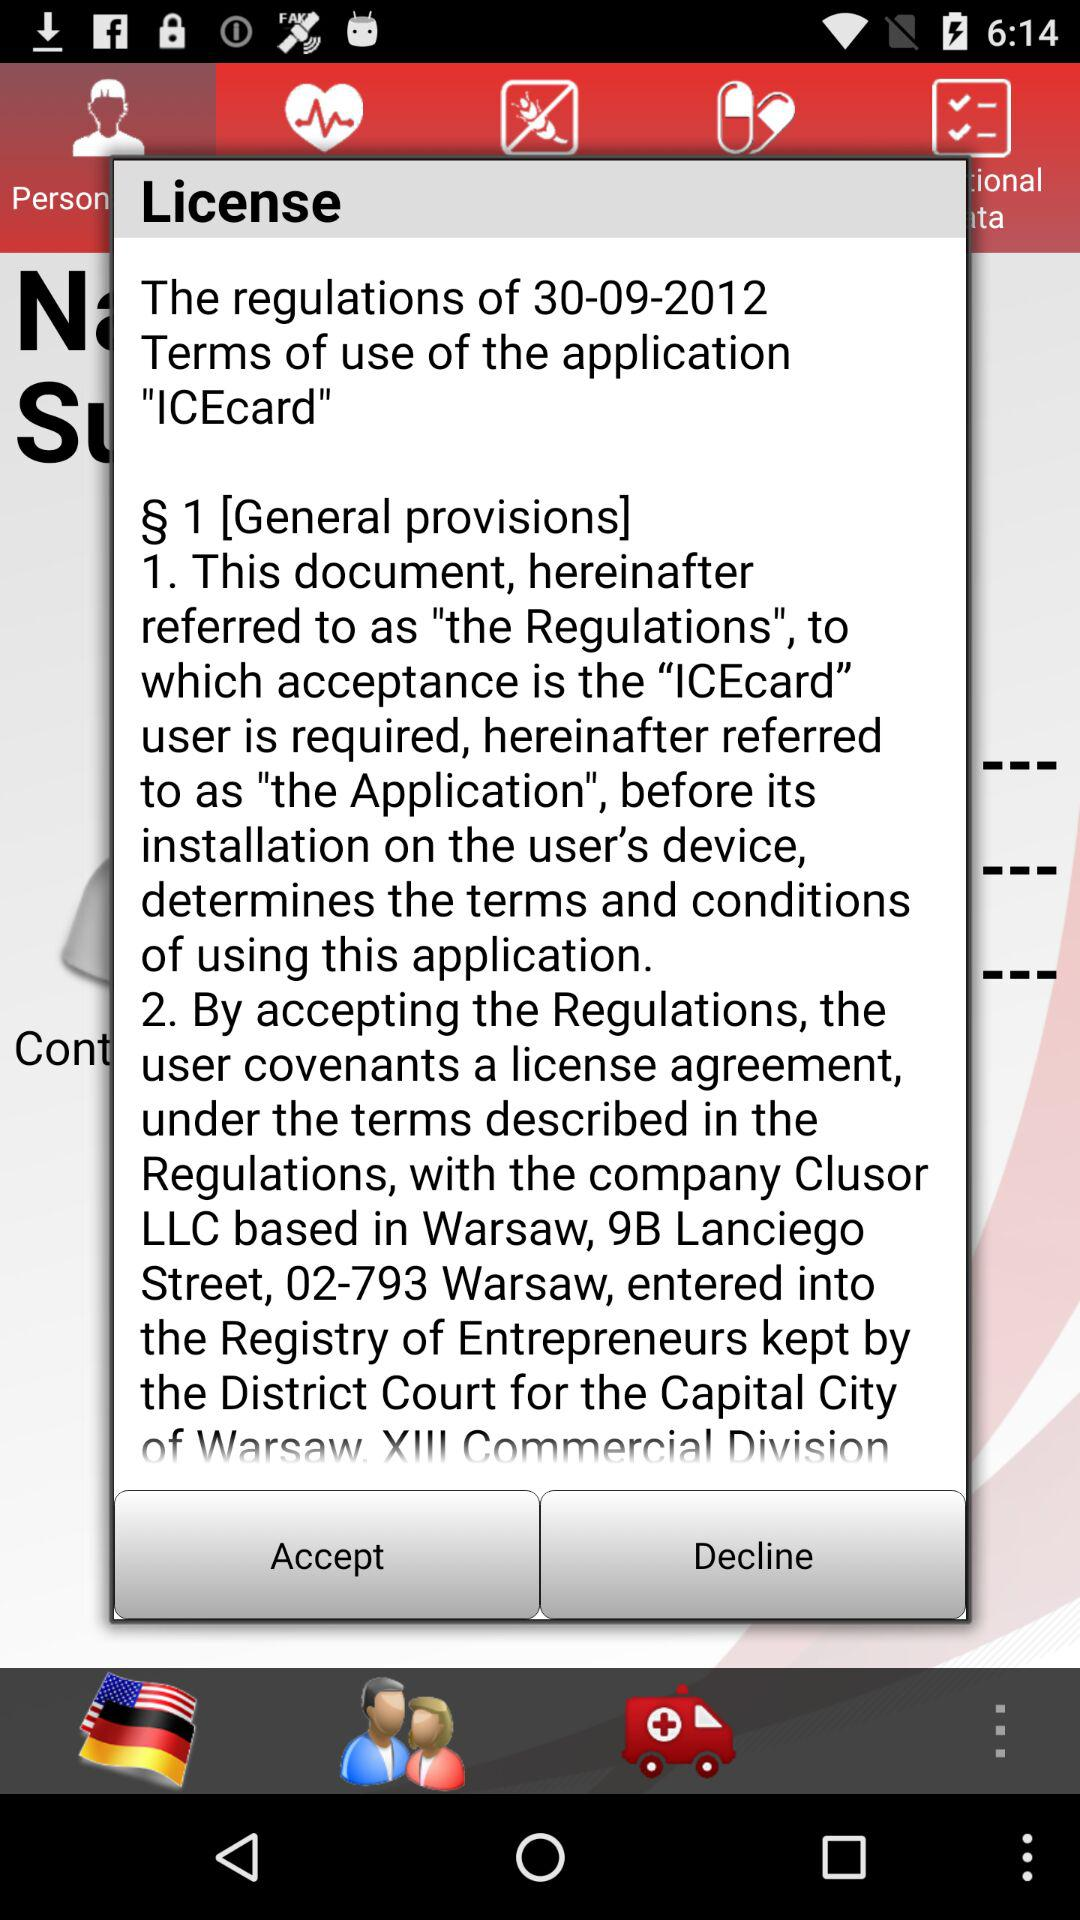Who is this application powered by?
When the provided information is insufficient, respond with <no answer>. <no answer> 